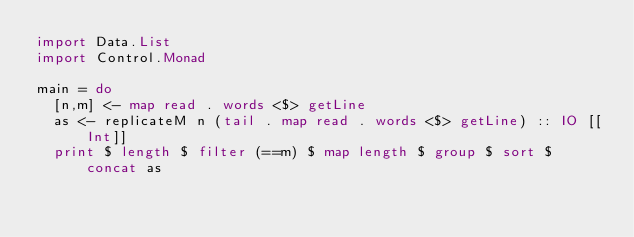<code> <loc_0><loc_0><loc_500><loc_500><_Haskell_>import Data.List
import Control.Monad

main = do
  [n,m] <- map read . words <$> getLine
  as <- replicateM n (tail . map read . words <$> getLine) :: IO [[Int]]
  print $ length $ filter (==m) $ map length $ group $ sort $ concat as </code> 